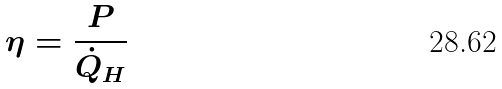<formula> <loc_0><loc_0><loc_500><loc_500>\eta = \frac { P } { \dot { Q } _ { H } }</formula> 